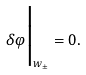Convert formula to latex. <formula><loc_0><loc_0><loc_500><loc_500>\delta \varphi \Big | _ { w _ { \pm } } = 0 .</formula> 